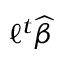Convert formula to latex. <formula><loc_0><loc_0><loc_500><loc_500>\ell ^ { t } { \widehat { \beta } }</formula> 